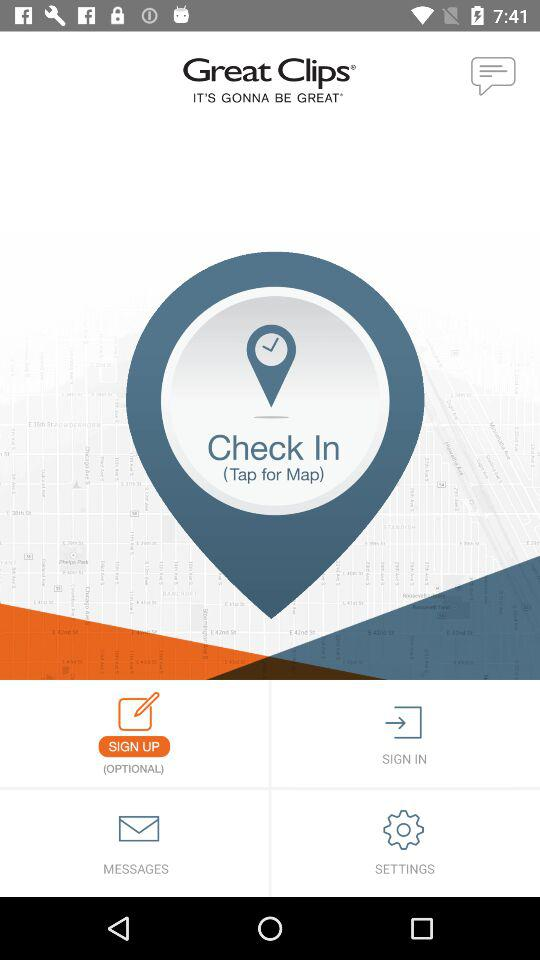What is the name of the application? The name of the application is "Check In". 